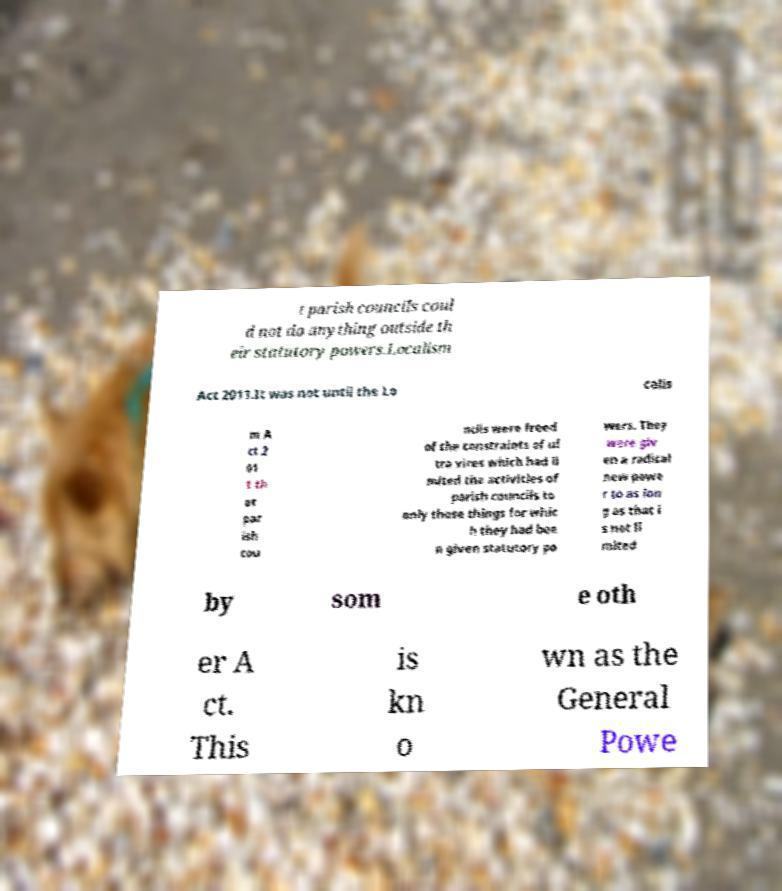There's text embedded in this image that I need extracted. Can you transcribe it verbatim? t parish councils coul d not do anything outside th eir statutory powers.Localism Act 2011.It was not until the Lo calis m A ct 2 01 1 th at par ish cou ncils were freed of the constraints of ul tra vires which had li mited the activities of parish councils to only those things for whic h they had bee n given statutory po wers. They were giv en a radical new powe r to as lon g as that i s not li mited by som e oth er A ct. This is kn o wn as the General Powe 